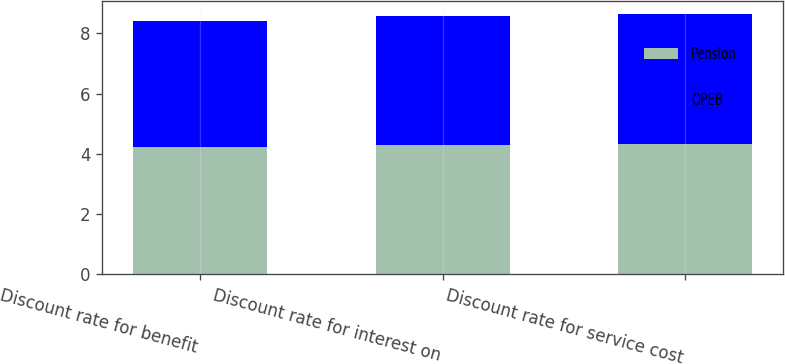Convert chart. <chart><loc_0><loc_0><loc_500><loc_500><stacked_bar_chart><ecel><fcel>Discount rate for benefit<fcel>Discount rate for interest on<fcel>Discount rate for service cost<nl><fcel>Pension<fcel>4.23<fcel>4.3<fcel>4.33<nl><fcel>OPEB<fcel>4.17<fcel>4.27<fcel>4.32<nl></chart> 